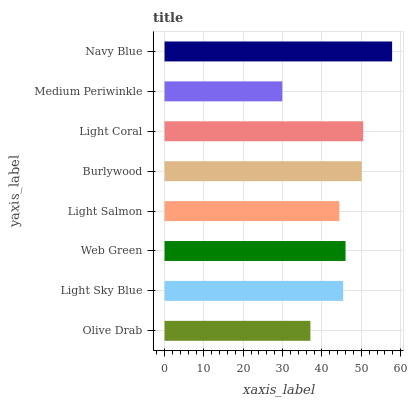Is Medium Periwinkle the minimum?
Answer yes or no. Yes. Is Navy Blue the maximum?
Answer yes or no. Yes. Is Light Sky Blue the minimum?
Answer yes or no. No. Is Light Sky Blue the maximum?
Answer yes or no. No. Is Light Sky Blue greater than Olive Drab?
Answer yes or no. Yes. Is Olive Drab less than Light Sky Blue?
Answer yes or no. Yes. Is Olive Drab greater than Light Sky Blue?
Answer yes or no. No. Is Light Sky Blue less than Olive Drab?
Answer yes or no. No. Is Web Green the high median?
Answer yes or no. Yes. Is Light Sky Blue the low median?
Answer yes or no. Yes. Is Light Salmon the high median?
Answer yes or no. No. Is Medium Periwinkle the low median?
Answer yes or no. No. 